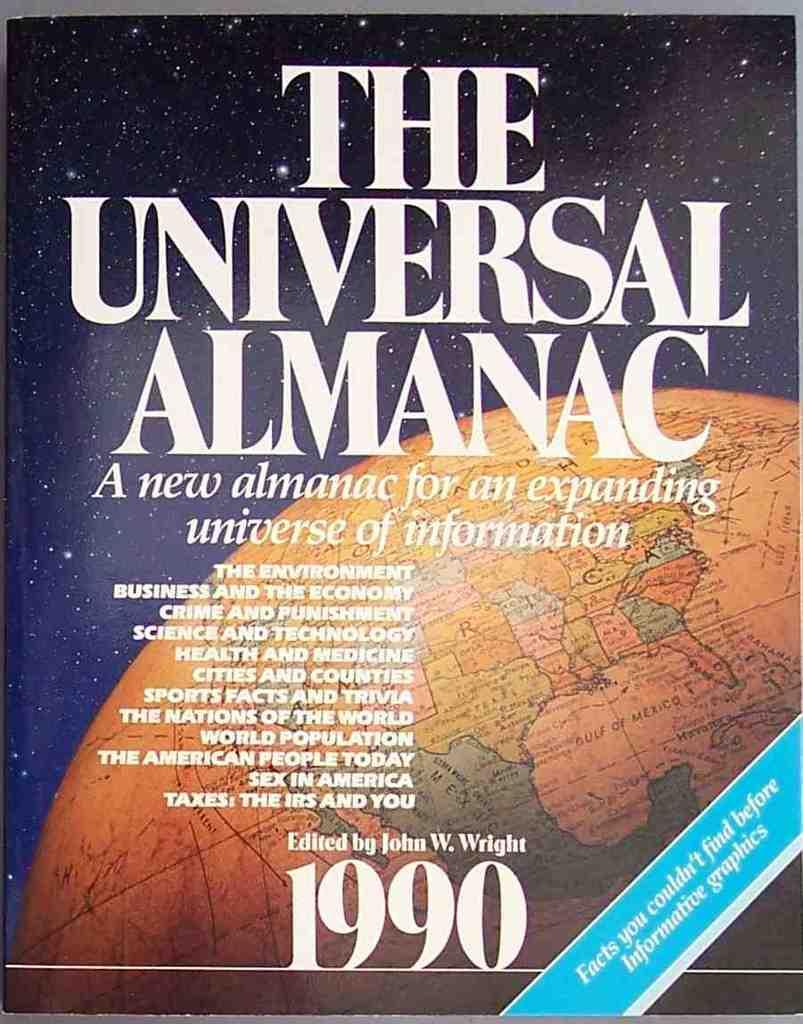<image>
Write a terse but informative summary of the picture. An edition of the Universal Almanac is from the year 1990. 